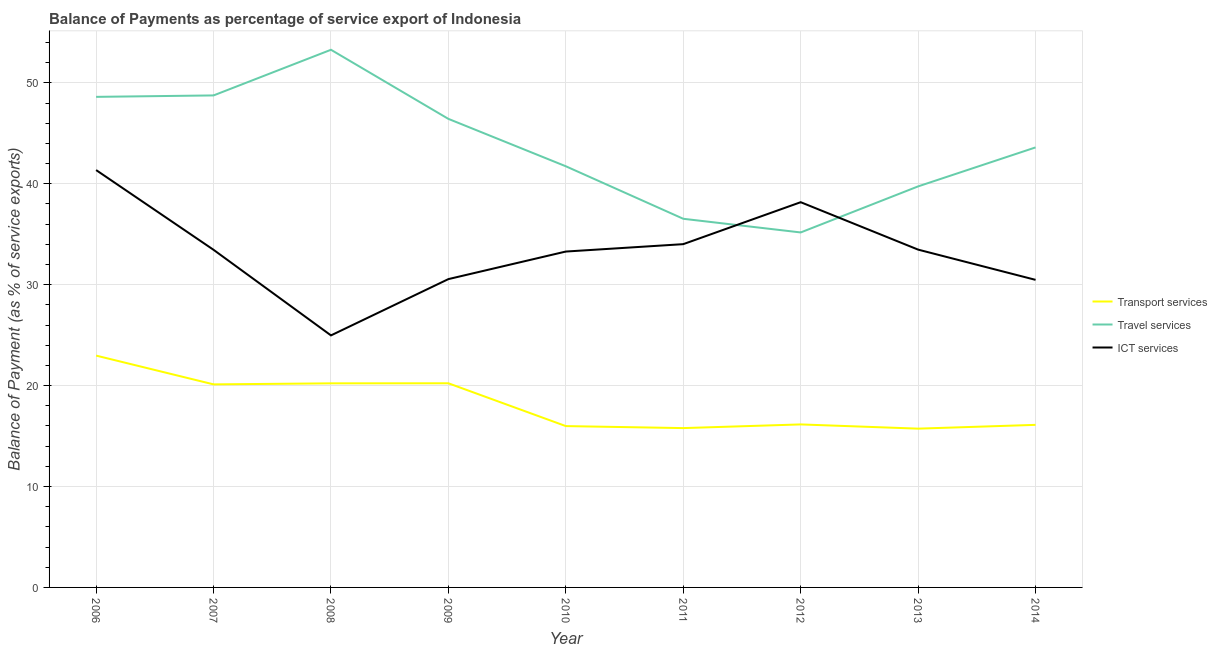How many different coloured lines are there?
Your response must be concise. 3. Does the line corresponding to balance of payment of transport services intersect with the line corresponding to balance of payment of travel services?
Keep it short and to the point. No. Is the number of lines equal to the number of legend labels?
Provide a succinct answer. Yes. What is the balance of payment of transport services in 2009?
Your answer should be compact. 20.23. Across all years, what is the maximum balance of payment of ict services?
Offer a terse response. 41.36. Across all years, what is the minimum balance of payment of travel services?
Keep it short and to the point. 35.18. What is the total balance of payment of transport services in the graph?
Your answer should be very brief. 163.34. What is the difference between the balance of payment of transport services in 2011 and that in 2014?
Ensure brevity in your answer.  -0.32. What is the difference between the balance of payment of travel services in 2012 and the balance of payment of ict services in 2008?
Your answer should be compact. 10.2. What is the average balance of payment of travel services per year?
Provide a succinct answer. 43.77. In the year 2010, what is the difference between the balance of payment of transport services and balance of payment of travel services?
Your response must be concise. -25.75. What is the ratio of the balance of payment of transport services in 2006 to that in 2008?
Make the answer very short. 1.14. Is the difference between the balance of payment of transport services in 2006 and 2014 greater than the difference between the balance of payment of ict services in 2006 and 2014?
Your response must be concise. No. What is the difference between the highest and the second highest balance of payment of travel services?
Ensure brevity in your answer.  4.52. What is the difference between the highest and the lowest balance of payment of transport services?
Your answer should be compact. 7.24. Are the values on the major ticks of Y-axis written in scientific E-notation?
Your answer should be very brief. No. Does the graph contain grids?
Ensure brevity in your answer.  Yes. Where does the legend appear in the graph?
Give a very brief answer. Center right. How are the legend labels stacked?
Offer a terse response. Vertical. What is the title of the graph?
Provide a short and direct response. Balance of Payments as percentage of service export of Indonesia. What is the label or title of the Y-axis?
Offer a very short reply. Balance of Payment (as % of service exports). What is the Balance of Payment (as % of service exports) in Transport services in 2006?
Keep it short and to the point. 22.98. What is the Balance of Payment (as % of service exports) of Travel services in 2006?
Provide a succinct answer. 48.62. What is the Balance of Payment (as % of service exports) of ICT services in 2006?
Your response must be concise. 41.36. What is the Balance of Payment (as % of service exports) in Transport services in 2007?
Provide a succinct answer. 20.12. What is the Balance of Payment (as % of service exports) in Travel services in 2007?
Ensure brevity in your answer.  48.76. What is the Balance of Payment (as % of service exports) of ICT services in 2007?
Your answer should be very brief. 33.46. What is the Balance of Payment (as % of service exports) in Transport services in 2008?
Offer a very short reply. 20.22. What is the Balance of Payment (as % of service exports) in Travel services in 2008?
Give a very brief answer. 53.28. What is the Balance of Payment (as % of service exports) in ICT services in 2008?
Offer a very short reply. 24.98. What is the Balance of Payment (as % of service exports) in Transport services in 2009?
Make the answer very short. 20.23. What is the Balance of Payment (as % of service exports) in Travel services in 2009?
Your answer should be very brief. 46.43. What is the Balance of Payment (as % of service exports) of ICT services in 2009?
Your answer should be very brief. 30.56. What is the Balance of Payment (as % of service exports) of Transport services in 2010?
Your response must be concise. 15.99. What is the Balance of Payment (as % of service exports) in Travel services in 2010?
Your response must be concise. 41.74. What is the Balance of Payment (as % of service exports) in ICT services in 2010?
Your answer should be compact. 33.29. What is the Balance of Payment (as % of service exports) of Transport services in 2011?
Provide a short and direct response. 15.79. What is the Balance of Payment (as % of service exports) in Travel services in 2011?
Give a very brief answer. 36.53. What is the Balance of Payment (as % of service exports) of ICT services in 2011?
Make the answer very short. 34.02. What is the Balance of Payment (as % of service exports) of Transport services in 2012?
Your response must be concise. 16.15. What is the Balance of Payment (as % of service exports) in Travel services in 2012?
Ensure brevity in your answer.  35.18. What is the Balance of Payment (as % of service exports) of ICT services in 2012?
Your response must be concise. 38.18. What is the Balance of Payment (as % of service exports) in Transport services in 2013?
Keep it short and to the point. 15.74. What is the Balance of Payment (as % of service exports) of Travel services in 2013?
Keep it short and to the point. 39.75. What is the Balance of Payment (as % of service exports) in ICT services in 2013?
Your answer should be compact. 33.48. What is the Balance of Payment (as % of service exports) of Transport services in 2014?
Make the answer very short. 16.11. What is the Balance of Payment (as % of service exports) of Travel services in 2014?
Make the answer very short. 43.61. What is the Balance of Payment (as % of service exports) in ICT services in 2014?
Your answer should be compact. 30.48. Across all years, what is the maximum Balance of Payment (as % of service exports) in Transport services?
Provide a short and direct response. 22.98. Across all years, what is the maximum Balance of Payment (as % of service exports) of Travel services?
Offer a very short reply. 53.28. Across all years, what is the maximum Balance of Payment (as % of service exports) in ICT services?
Provide a short and direct response. 41.36. Across all years, what is the minimum Balance of Payment (as % of service exports) in Transport services?
Offer a terse response. 15.74. Across all years, what is the minimum Balance of Payment (as % of service exports) of Travel services?
Offer a terse response. 35.18. Across all years, what is the minimum Balance of Payment (as % of service exports) of ICT services?
Offer a terse response. 24.98. What is the total Balance of Payment (as % of service exports) of Transport services in the graph?
Keep it short and to the point. 163.34. What is the total Balance of Payment (as % of service exports) of Travel services in the graph?
Offer a terse response. 393.9. What is the total Balance of Payment (as % of service exports) of ICT services in the graph?
Ensure brevity in your answer.  299.8. What is the difference between the Balance of Payment (as % of service exports) of Transport services in 2006 and that in 2007?
Provide a succinct answer. 2.85. What is the difference between the Balance of Payment (as % of service exports) in Travel services in 2006 and that in 2007?
Offer a terse response. -0.14. What is the difference between the Balance of Payment (as % of service exports) in ICT services in 2006 and that in 2007?
Ensure brevity in your answer.  7.9. What is the difference between the Balance of Payment (as % of service exports) of Transport services in 2006 and that in 2008?
Your response must be concise. 2.75. What is the difference between the Balance of Payment (as % of service exports) of Travel services in 2006 and that in 2008?
Provide a short and direct response. -4.67. What is the difference between the Balance of Payment (as % of service exports) in ICT services in 2006 and that in 2008?
Offer a terse response. 16.39. What is the difference between the Balance of Payment (as % of service exports) of Transport services in 2006 and that in 2009?
Make the answer very short. 2.74. What is the difference between the Balance of Payment (as % of service exports) of Travel services in 2006 and that in 2009?
Ensure brevity in your answer.  2.18. What is the difference between the Balance of Payment (as % of service exports) of ICT services in 2006 and that in 2009?
Your answer should be very brief. 10.81. What is the difference between the Balance of Payment (as % of service exports) in Transport services in 2006 and that in 2010?
Offer a very short reply. 6.99. What is the difference between the Balance of Payment (as % of service exports) in Travel services in 2006 and that in 2010?
Your response must be concise. 6.88. What is the difference between the Balance of Payment (as % of service exports) in ICT services in 2006 and that in 2010?
Keep it short and to the point. 8.07. What is the difference between the Balance of Payment (as % of service exports) in Transport services in 2006 and that in 2011?
Provide a short and direct response. 7.19. What is the difference between the Balance of Payment (as % of service exports) of Travel services in 2006 and that in 2011?
Provide a succinct answer. 12.08. What is the difference between the Balance of Payment (as % of service exports) of ICT services in 2006 and that in 2011?
Offer a terse response. 7.34. What is the difference between the Balance of Payment (as % of service exports) in Transport services in 2006 and that in 2012?
Offer a terse response. 6.82. What is the difference between the Balance of Payment (as % of service exports) of Travel services in 2006 and that in 2012?
Offer a very short reply. 13.44. What is the difference between the Balance of Payment (as % of service exports) in ICT services in 2006 and that in 2012?
Offer a terse response. 3.18. What is the difference between the Balance of Payment (as % of service exports) of Transport services in 2006 and that in 2013?
Your answer should be very brief. 7.24. What is the difference between the Balance of Payment (as % of service exports) in Travel services in 2006 and that in 2013?
Your response must be concise. 8.87. What is the difference between the Balance of Payment (as % of service exports) in ICT services in 2006 and that in 2013?
Offer a very short reply. 7.88. What is the difference between the Balance of Payment (as % of service exports) of Transport services in 2006 and that in 2014?
Provide a short and direct response. 6.87. What is the difference between the Balance of Payment (as % of service exports) in Travel services in 2006 and that in 2014?
Provide a succinct answer. 5.01. What is the difference between the Balance of Payment (as % of service exports) of ICT services in 2006 and that in 2014?
Give a very brief answer. 10.88. What is the difference between the Balance of Payment (as % of service exports) of Transport services in 2007 and that in 2008?
Give a very brief answer. -0.1. What is the difference between the Balance of Payment (as % of service exports) in Travel services in 2007 and that in 2008?
Provide a short and direct response. -4.52. What is the difference between the Balance of Payment (as % of service exports) of ICT services in 2007 and that in 2008?
Your response must be concise. 8.48. What is the difference between the Balance of Payment (as % of service exports) in Transport services in 2007 and that in 2009?
Offer a terse response. -0.11. What is the difference between the Balance of Payment (as % of service exports) in Travel services in 2007 and that in 2009?
Provide a succinct answer. 2.32. What is the difference between the Balance of Payment (as % of service exports) in ICT services in 2007 and that in 2009?
Make the answer very short. 2.9. What is the difference between the Balance of Payment (as % of service exports) of Transport services in 2007 and that in 2010?
Your answer should be very brief. 4.13. What is the difference between the Balance of Payment (as % of service exports) in Travel services in 2007 and that in 2010?
Provide a short and direct response. 7.02. What is the difference between the Balance of Payment (as % of service exports) in ICT services in 2007 and that in 2010?
Provide a short and direct response. 0.17. What is the difference between the Balance of Payment (as % of service exports) in Transport services in 2007 and that in 2011?
Keep it short and to the point. 4.33. What is the difference between the Balance of Payment (as % of service exports) in Travel services in 2007 and that in 2011?
Offer a terse response. 12.22. What is the difference between the Balance of Payment (as % of service exports) of ICT services in 2007 and that in 2011?
Ensure brevity in your answer.  -0.56. What is the difference between the Balance of Payment (as % of service exports) of Transport services in 2007 and that in 2012?
Your answer should be compact. 3.97. What is the difference between the Balance of Payment (as % of service exports) of Travel services in 2007 and that in 2012?
Give a very brief answer. 13.58. What is the difference between the Balance of Payment (as % of service exports) of ICT services in 2007 and that in 2012?
Provide a short and direct response. -4.72. What is the difference between the Balance of Payment (as % of service exports) in Transport services in 2007 and that in 2013?
Give a very brief answer. 4.39. What is the difference between the Balance of Payment (as % of service exports) of Travel services in 2007 and that in 2013?
Offer a very short reply. 9.01. What is the difference between the Balance of Payment (as % of service exports) of ICT services in 2007 and that in 2013?
Keep it short and to the point. -0.02. What is the difference between the Balance of Payment (as % of service exports) in Transport services in 2007 and that in 2014?
Offer a very short reply. 4.01. What is the difference between the Balance of Payment (as % of service exports) in Travel services in 2007 and that in 2014?
Provide a short and direct response. 5.15. What is the difference between the Balance of Payment (as % of service exports) of ICT services in 2007 and that in 2014?
Your response must be concise. 2.98. What is the difference between the Balance of Payment (as % of service exports) of Transport services in 2008 and that in 2009?
Your response must be concise. -0.01. What is the difference between the Balance of Payment (as % of service exports) of Travel services in 2008 and that in 2009?
Your answer should be very brief. 6.85. What is the difference between the Balance of Payment (as % of service exports) of ICT services in 2008 and that in 2009?
Your answer should be very brief. -5.58. What is the difference between the Balance of Payment (as % of service exports) in Transport services in 2008 and that in 2010?
Offer a very short reply. 4.24. What is the difference between the Balance of Payment (as % of service exports) of Travel services in 2008 and that in 2010?
Your answer should be very brief. 11.55. What is the difference between the Balance of Payment (as % of service exports) of ICT services in 2008 and that in 2010?
Give a very brief answer. -8.31. What is the difference between the Balance of Payment (as % of service exports) in Transport services in 2008 and that in 2011?
Your response must be concise. 4.43. What is the difference between the Balance of Payment (as % of service exports) of Travel services in 2008 and that in 2011?
Provide a short and direct response. 16.75. What is the difference between the Balance of Payment (as % of service exports) of ICT services in 2008 and that in 2011?
Make the answer very short. -9.04. What is the difference between the Balance of Payment (as % of service exports) in Transport services in 2008 and that in 2012?
Give a very brief answer. 4.07. What is the difference between the Balance of Payment (as % of service exports) in Travel services in 2008 and that in 2012?
Make the answer very short. 18.1. What is the difference between the Balance of Payment (as % of service exports) in ICT services in 2008 and that in 2012?
Give a very brief answer. -13.2. What is the difference between the Balance of Payment (as % of service exports) in Transport services in 2008 and that in 2013?
Your answer should be compact. 4.49. What is the difference between the Balance of Payment (as % of service exports) in Travel services in 2008 and that in 2013?
Offer a very short reply. 13.54. What is the difference between the Balance of Payment (as % of service exports) in ICT services in 2008 and that in 2013?
Ensure brevity in your answer.  -8.5. What is the difference between the Balance of Payment (as % of service exports) of Transport services in 2008 and that in 2014?
Offer a terse response. 4.11. What is the difference between the Balance of Payment (as % of service exports) in Travel services in 2008 and that in 2014?
Your answer should be very brief. 9.68. What is the difference between the Balance of Payment (as % of service exports) of ICT services in 2008 and that in 2014?
Offer a terse response. -5.5. What is the difference between the Balance of Payment (as % of service exports) of Transport services in 2009 and that in 2010?
Give a very brief answer. 4.24. What is the difference between the Balance of Payment (as % of service exports) in Travel services in 2009 and that in 2010?
Offer a very short reply. 4.7. What is the difference between the Balance of Payment (as % of service exports) in ICT services in 2009 and that in 2010?
Ensure brevity in your answer.  -2.73. What is the difference between the Balance of Payment (as % of service exports) of Transport services in 2009 and that in 2011?
Your answer should be very brief. 4.44. What is the difference between the Balance of Payment (as % of service exports) in Travel services in 2009 and that in 2011?
Provide a short and direct response. 9.9. What is the difference between the Balance of Payment (as % of service exports) of ICT services in 2009 and that in 2011?
Provide a short and direct response. -3.46. What is the difference between the Balance of Payment (as % of service exports) in Transport services in 2009 and that in 2012?
Your response must be concise. 4.08. What is the difference between the Balance of Payment (as % of service exports) of Travel services in 2009 and that in 2012?
Offer a terse response. 11.25. What is the difference between the Balance of Payment (as % of service exports) in ICT services in 2009 and that in 2012?
Offer a very short reply. -7.62. What is the difference between the Balance of Payment (as % of service exports) of Transport services in 2009 and that in 2013?
Provide a succinct answer. 4.49. What is the difference between the Balance of Payment (as % of service exports) of Travel services in 2009 and that in 2013?
Make the answer very short. 6.69. What is the difference between the Balance of Payment (as % of service exports) in ICT services in 2009 and that in 2013?
Keep it short and to the point. -2.92. What is the difference between the Balance of Payment (as % of service exports) in Transport services in 2009 and that in 2014?
Provide a short and direct response. 4.12. What is the difference between the Balance of Payment (as % of service exports) in Travel services in 2009 and that in 2014?
Keep it short and to the point. 2.83. What is the difference between the Balance of Payment (as % of service exports) of ICT services in 2009 and that in 2014?
Provide a short and direct response. 0.08. What is the difference between the Balance of Payment (as % of service exports) in Transport services in 2010 and that in 2011?
Your answer should be very brief. 0.2. What is the difference between the Balance of Payment (as % of service exports) of Travel services in 2010 and that in 2011?
Ensure brevity in your answer.  5.2. What is the difference between the Balance of Payment (as % of service exports) of ICT services in 2010 and that in 2011?
Make the answer very short. -0.73. What is the difference between the Balance of Payment (as % of service exports) of Transport services in 2010 and that in 2012?
Give a very brief answer. -0.17. What is the difference between the Balance of Payment (as % of service exports) in Travel services in 2010 and that in 2012?
Make the answer very short. 6.56. What is the difference between the Balance of Payment (as % of service exports) in ICT services in 2010 and that in 2012?
Your response must be concise. -4.89. What is the difference between the Balance of Payment (as % of service exports) in Transport services in 2010 and that in 2013?
Your answer should be compact. 0.25. What is the difference between the Balance of Payment (as % of service exports) in Travel services in 2010 and that in 2013?
Ensure brevity in your answer.  1.99. What is the difference between the Balance of Payment (as % of service exports) of ICT services in 2010 and that in 2013?
Your response must be concise. -0.19. What is the difference between the Balance of Payment (as % of service exports) in Transport services in 2010 and that in 2014?
Provide a short and direct response. -0.12. What is the difference between the Balance of Payment (as % of service exports) in Travel services in 2010 and that in 2014?
Keep it short and to the point. -1.87. What is the difference between the Balance of Payment (as % of service exports) of ICT services in 2010 and that in 2014?
Keep it short and to the point. 2.81. What is the difference between the Balance of Payment (as % of service exports) in Transport services in 2011 and that in 2012?
Provide a short and direct response. -0.36. What is the difference between the Balance of Payment (as % of service exports) in Travel services in 2011 and that in 2012?
Offer a very short reply. 1.35. What is the difference between the Balance of Payment (as % of service exports) in ICT services in 2011 and that in 2012?
Your response must be concise. -4.16. What is the difference between the Balance of Payment (as % of service exports) in Transport services in 2011 and that in 2013?
Keep it short and to the point. 0.05. What is the difference between the Balance of Payment (as % of service exports) of Travel services in 2011 and that in 2013?
Give a very brief answer. -3.21. What is the difference between the Balance of Payment (as % of service exports) in ICT services in 2011 and that in 2013?
Offer a very short reply. 0.54. What is the difference between the Balance of Payment (as % of service exports) of Transport services in 2011 and that in 2014?
Your answer should be compact. -0.32. What is the difference between the Balance of Payment (as % of service exports) of Travel services in 2011 and that in 2014?
Ensure brevity in your answer.  -7.07. What is the difference between the Balance of Payment (as % of service exports) of ICT services in 2011 and that in 2014?
Make the answer very short. 3.54. What is the difference between the Balance of Payment (as % of service exports) of Transport services in 2012 and that in 2013?
Offer a very short reply. 0.42. What is the difference between the Balance of Payment (as % of service exports) of Travel services in 2012 and that in 2013?
Offer a terse response. -4.57. What is the difference between the Balance of Payment (as % of service exports) of ICT services in 2012 and that in 2013?
Your response must be concise. 4.7. What is the difference between the Balance of Payment (as % of service exports) of Transport services in 2012 and that in 2014?
Keep it short and to the point. 0.04. What is the difference between the Balance of Payment (as % of service exports) in Travel services in 2012 and that in 2014?
Provide a succinct answer. -8.43. What is the difference between the Balance of Payment (as % of service exports) of ICT services in 2012 and that in 2014?
Offer a terse response. 7.7. What is the difference between the Balance of Payment (as % of service exports) of Transport services in 2013 and that in 2014?
Offer a very short reply. -0.37. What is the difference between the Balance of Payment (as % of service exports) in Travel services in 2013 and that in 2014?
Keep it short and to the point. -3.86. What is the difference between the Balance of Payment (as % of service exports) of ICT services in 2013 and that in 2014?
Your answer should be compact. 3. What is the difference between the Balance of Payment (as % of service exports) in Transport services in 2006 and the Balance of Payment (as % of service exports) in Travel services in 2007?
Your answer should be compact. -25.78. What is the difference between the Balance of Payment (as % of service exports) in Transport services in 2006 and the Balance of Payment (as % of service exports) in ICT services in 2007?
Your answer should be compact. -10.48. What is the difference between the Balance of Payment (as % of service exports) of Travel services in 2006 and the Balance of Payment (as % of service exports) of ICT services in 2007?
Offer a very short reply. 15.16. What is the difference between the Balance of Payment (as % of service exports) of Transport services in 2006 and the Balance of Payment (as % of service exports) of Travel services in 2008?
Your answer should be very brief. -30.31. What is the difference between the Balance of Payment (as % of service exports) in Transport services in 2006 and the Balance of Payment (as % of service exports) in ICT services in 2008?
Your answer should be very brief. -2. What is the difference between the Balance of Payment (as % of service exports) of Travel services in 2006 and the Balance of Payment (as % of service exports) of ICT services in 2008?
Offer a terse response. 23.64. What is the difference between the Balance of Payment (as % of service exports) in Transport services in 2006 and the Balance of Payment (as % of service exports) in Travel services in 2009?
Your response must be concise. -23.46. What is the difference between the Balance of Payment (as % of service exports) of Transport services in 2006 and the Balance of Payment (as % of service exports) of ICT services in 2009?
Your answer should be compact. -7.58. What is the difference between the Balance of Payment (as % of service exports) in Travel services in 2006 and the Balance of Payment (as % of service exports) in ICT services in 2009?
Your answer should be very brief. 18.06. What is the difference between the Balance of Payment (as % of service exports) of Transport services in 2006 and the Balance of Payment (as % of service exports) of Travel services in 2010?
Offer a very short reply. -18.76. What is the difference between the Balance of Payment (as % of service exports) of Transport services in 2006 and the Balance of Payment (as % of service exports) of ICT services in 2010?
Your answer should be compact. -10.31. What is the difference between the Balance of Payment (as % of service exports) in Travel services in 2006 and the Balance of Payment (as % of service exports) in ICT services in 2010?
Make the answer very short. 15.33. What is the difference between the Balance of Payment (as % of service exports) of Transport services in 2006 and the Balance of Payment (as % of service exports) of Travel services in 2011?
Offer a terse response. -13.56. What is the difference between the Balance of Payment (as % of service exports) in Transport services in 2006 and the Balance of Payment (as % of service exports) in ICT services in 2011?
Your answer should be very brief. -11.04. What is the difference between the Balance of Payment (as % of service exports) in Travel services in 2006 and the Balance of Payment (as % of service exports) in ICT services in 2011?
Provide a succinct answer. 14.6. What is the difference between the Balance of Payment (as % of service exports) in Transport services in 2006 and the Balance of Payment (as % of service exports) in Travel services in 2012?
Ensure brevity in your answer.  -12.2. What is the difference between the Balance of Payment (as % of service exports) of Transport services in 2006 and the Balance of Payment (as % of service exports) of ICT services in 2012?
Your answer should be very brief. -15.2. What is the difference between the Balance of Payment (as % of service exports) in Travel services in 2006 and the Balance of Payment (as % of service exports) in ICT services in 2012?
Keep it short and to the point. 10.44. What is the difference between the Balance of Payment (as % of service exports) in Transport services in 2006 and the Balance of Payment (as % of service exports) in Travel services in 2013?
Provide a short and direct response. -16.77. What is the difference between the Balance of Payment (as % of service exports) of Transport services in 2006 and the Balance of Payment (as % of service exports) of ICT services in 2013?
Offer a very short reply. -10.5. What is the difference between the Balance of Payment (as % of service exports) of Travel services in 2006 and the Balance of Payment (as % of service exports) of ICT services in 2013?
Offer a very short reply. 15.14. What is the difference between the Balance of Payment (as % of service exports) of Transport services in 2006 and the Balance of Payment (as % of service exports) of Travel services in 2014?
Offer a very short reply. -20.63. What is the difference between the Balance of Payment (as % of service exports) in Transport services in 2006 and the Balance of Payment (as % of service exports) in ICT services in 2014?
Keep it short and to the point. -7.5. What is the difference between the Balance of Payment (as % of service exports) in Travel services in 2006 and the Balance of Payment (as % of service exports) in ICT services in 2014?
Keep it short and to the point. 18.14. What is the difference between the Balance of Payment (as % of service exports) in Transport services in 2007 and the Balance of Payment (as % of service exports) in Travel services in 2008?
Your response must be concise. -33.16. What is the difference between the Balance of Payment (as % of service exports) in Transport services in 2007 and the Balance of Payment (as % of service exports) in ICT services in 2008?
Provide a succinct answer. -4.85. What is the difference between the Balance of Payment (as % of service exports) in Travel services in 2007 and the Balance of Payment (as % of service exports) in ICT services in 2008?
Keep it short and to the point. 23.78. What is the difference between the Balance of Payment (as % of service exports) of Transport services in 2007 and the Balance of Payment (as % of service exports) of Travel services in 2009?
Your answer should be very brief. -26.31. What is the difference between the Balance of Payment (as % of service exports) in Transport services in 2007 and the Balance of Payment (as % of service exports) in ICT services in 2009?
Your response must be concise. -10.43. What is the difference between the Balance of Payment (as % of service exports) of Travel services in 2007 and the Balance of Payment (as % of service exports) of ICT services in 2009?
Offer a very short reply. 18.2. What is the difference between the Balance of Payment (as % of service exports) in Transport services in 2007 and the Balance of Payment (as % of service exports) in Travel services in 2010?
Offer a terse response. -21.61. What is the difference between the Balance of Payment (as % of service exports) of Transport services in 2007 and the Balance of Payment (as % of service exports) of ICT services in 2010?
Ensure brevity in your answer.  -13.16. What is the difference between the Balance of Payment (as % of service exports) of Travel services in 2007 and the Balance of Payment (as % of service exports) of ICT services in 2010?
Offer a terse response. 15.47. What is the difference between the Balance of Payment (as % of service exports) in Transport services in 2007 and the Balance of Payment (as % of service exports) in Travel services in 2011?
Provide a succinct answer. -16.41. What is the difference between the Balance of Payment (as % of service exports) in Transport services in 2007 and the Balance of Payment (as % of service exports) in ICT services in 2011?
Your response must be concise. -13.9. What is the difference between the Balance of Payment (as % of service exports) in Travel services in 2007 and the Balance of Payment (as % of service exports) in ICT services in 2011?
Ensure brevity in your answer.  14.74. What is the difference between the Balance of Payment (as % of service exports) of Transport services in 2007 and the Balance of Payment (as % of service exports) of Travel services in 2012?
Offer a very short reply. -15.06. What is the difference between the Balance of Payment (as % of service exports) of Transport services in 2007 and the Balance of Payment (as % of service exports) of ICT services in 2012?
Keep it short and to the point. -18.05. What is the difference between the Balance of Payment (as % of service exports) of Travel services in 2007 and the Balance of Payment (as % of service exports) of ICT services in 2012?
Provide a succinct answer. 10.58. What is the difference between the Balance of Payment (as % of service exports) in Transport services in 2007 and the Balance of Payment (as % of service exports) in Travel services in 2013?
Ensure brevity in your answer.  -19.62. What is the difference between the Balance of Payment (as % of service exports) of Transport services in 2007 and the Balance of Payment (as % of service exports) of ICT services in 2013?
Provide a short and direct response. -13.35. What is the difference between the Balance of Payment (as % of service exports) of Travel services in 2007 and the Balance of Payment (as % of service exports) of ICT services in 2013?
Make the answer very short. 15.28. What is the difference between the Balance of Payment (as % of service exports) in Transport services in 2007 and the Balance of Payment (as % of service exports) in Travel services in 2014?
Provide a short and direct response. -23.48. What is the difference between the Balance of Payment (as % of service exports) in Transport services in 2007 and the Balance of Payment (as % of service exports) in ICT services in 2014?
Make the answer very short. -10.36. What is the difference between the Balance of Payment (as % of service exports) of Travel services in 2007 and the Balance of Payment (as % of service exports) of ICT services in 2014?
Give a very brief answer. 18.28. What is the difference between the Balance of Payment (as % of service exports) of Transport services in 2008 and the Balance of Payment (as % of service exports) of Travel services in 2009?
Make the answer very short. -26.21. What is the difference between the Balance of Payment (as % of service exports) of Transport services in 2008 and the Balance of Payment (as % of service exports) of ICT services in 2009?
Offer a very short reply. -10.33. What is the difference between the Balance of Payment (as % of service exports) in Travel services in 2008 and the Balance of Payment (as % of service exports) in ICT services in 2009?
Your answer should be very brief. 22.73. What is the difference between the Balance of Payment (as % of service exports) in Transport services in 2008 and the Balance of Payment (as % of service exports) in Travel services in 2010?
Provide a short and direct response. -21.51. What is the difference between the Balance of Payment (as % of service exports) of Transport services in 2008 and the Balance of Payment (as % of service exports) of ICT services in 2010?
Offer a very short reply. -13.06. What is the difference between the Balance of Payment (as % of service exports) of Travel services in 2008 and the Balance of Payment (as % of service exports) of ICT services in 2010?
Your answer should be very brief. 20. What is the difference between the Balance of Payment (as % of service exports) in Transport services in 2008 and the Balance of Payment (as % of service exports) in Travel services in 2011?
Ensure brevity in your answer.  -16.31. What is the difference between the Balance of Payment (as % of service exports) of Transport services in 2008 and the Balance of Payment (as % of service exports) of ICT services in 2011?
Offer a terse response. -13.79. What is the difference between the Balance of Payment (as % of service exports) of Travel services in 2008 and the Balance of Payment (as % of service exports) of ICT services in 2011?
Your answer should be very brief. 19.26. What is the difference between the Balance of Payment (as % of service exports) of Transport services in 2008 and the Balance of Payment (as % of service exports) of Travel services in 2012?
Provide a succinct answer. -14.95. What is the difference between the Balance of Payment (as % of service exports) in Transport services in 2008 and the Balance of Payment (as % of service exports) in ICT services in 2012?
Offer a terse response. -17.95. What is the difference between the Balance of Payment (as % of service exports) of Travel services in 2008 and the Balance of Payment (as % of service exports) of ICT services in 2012?
Offer a very short reply. 15.11. What is the difference between the Balance of Payment (as % of service exports) in Transport services in 2008 and the Balance of Payment (as % of service exports) in Travel services in 2013?
Your answer should be compact. -19.52. What is the difference between the Balance of Payment (as % of service exports) of Transport services in 2008 and the Balance of Payment (as % of service exports) of ICT services in 2013?
Your response must be concise. -13.25. What is the difference between the Balance of Payment (as % of service exports) in Travel services in 2008 and the Balance of Payment (as % of service exports) in ICT services in 2013?
Ensure brevity in your answer.  19.81. What is the difference between the Balance of Payment (as % of service exports) of Transport services in 2008 and the Balance of Payment (as % of service exports) of Travel services in 2014?
Provide a succinct answer. -23.38. What is the difference between the Balance of Payment (as % of service exports) in Transport services in 2008 and the Balance of Payment (as % of service exports) in ICT services in 2014?
Keep it short and to the point. -10.26. What is the difference between the Balance of Payment (as % of service exports) of Travel services in 2008 and the Balance of Payment (as % of service exports) of ICT services in 2014?
Your answer should be very brief. 22.8. What is the difference between the Balance of Payment (as % of service exports) in Transport services in 2009 and the Balance of Payment (as % of service exports) in Travel services in 2010?
Offer a terse response. -21.51. What is the difference between the Balance of Payment (as % of service exports) in Transport services in 2009 and the Balance of Payment (as % of service exports) in ICT services in 2010?
Give a very brief answer. -13.06. What is the difference between the Balance of Payment (as % of service exports) in Travel services in 2009 and the Balance of Payment (as % of service exports) in ICT services in 2010?
Your answer should be compact. 13.15. What is the difference between the Balance of Payment (as % of service exports) of Transport services in 2009 and the Balance of Payment (as % of service exports) of Travel services in 2011?
Make the answer very short. -16.3. What is the difference between the Balance of Payment (as % of service exports) in Transport services in 2009 and the Balance of Payment (as % of service exports) in ICT services in 2011?
Keep it short and to the point. -13.79. What is the difference between the Balance of Payment (as % of service exports) of Travel services in 2009 and the Balance of Payment (as % of service exports) of ICT services in 2011?
Keep it short and to the point. 12.41. What is the difference between the Balance of Payment (as % of service exports) in Transport services in 2009 and the Balance of Payment (as % of service exports) in Travel services in 2012?
Ensure brevity in your answer.  -14.95. What is the difference between the Balance of Payment (as % of service exports) of Transport services in 2009 and the Balance of Payment (as % of service exports) of ICT services in 2012?
Your answer should be compact. -17.95. What is the difference between the Balance of Payment (as % of service exports) of Travel services in 2009 and the Balance of Payment (as % of service exports) of ICT services in 2012?
Your response must be concise. 8.26. What is the difference between the Balance of Payment (as % of service exports) in Transport services in 2009 and the Balance of Payment (as % of service exports) in Travel services in 2013?
Offer a very short reply. -19.51. What is the difference between the Balance of Payment (as % of service exports) of Transport services in 2009 and the Balance of Payment (as % of service exports) of ICT services in 2013?
Give a very brief answer. -13.25. What is the difference between the Balance of Payment (as % of service exports) in Travel services in 2009 and the Balance of Payment (as % of service exports) in ICT services in 2013?
Keep it short and to the point. 12.96. What is the difference between the Balance of Payment (as % of service exports) of Transport services in 2009 and the Balance of Payment (as % of service exports) of Travel services in 2014?
Your answer should be compact. -23.38. What is the difference between the Balance of Payment (as % of service exports) in Transport services in 2009 and the Balance of Payment (as % of service exports) in ICT services in 2014?
Give a very brief answer. -10.25. What is the difference between the Balance of Payment (as % of service exports) of Travel services in 2009 and the Balance of Payment (as % of service exports) of ICT services in 2014?
Your answer should be compact. 15.95. What is the difference between the Balance of Payment (as % of service exports) of Transport services in 2010 and the Balance of Payment (as % of service exports) of Travel services in 2011?
Keep it short and to the point. -20.55. What is the difference between the Balance of Payment (as % of service exports) of Transport services in 2010 and the Balance of Payment (as % of service exports) of ICT services in 2011?
Keep it short and to the point. -18.03. What is the difference between the Balance of Payment (as % of service exports) in Travel services in 2010 and the Balance of Payment (as % of service exports) in ICT services in 2011?
Your response must be concise. 7.72. What is the difference between the Balance of Payment (as % of service exports) of Transport services in 2010 and the Balance of Payment (as % of service exports) of Travel services in 2012?
Provide a succinct answer. -19.19. What is the difference between the Balance of Payment (as % of service exports) in Transport services in 2010 and the Balance of Payment (as % of service exports) in ICT services in 2012?
Make the answer very short. -22.19. What is the difference between the Balance of Payment (as % of service exports) of Travel services in 2010 and the Balance of Payment (as % of service exports) of ICT services in 2012?
Provide a short and direct response. 3.56. What is the difference between the Balance of Payment (as % of service exports) of Transport services in 2010 and the Balance of Payment (as % of service exports) of Travel services in 2013?
Your answer should be compact. -23.76. What is the difference between the Balance of Payment (as % of service exports) in Transport services in 2010 and the Balance of Payment (as % of service exports) in ICT services in 2013?
Ensure brevity in your answer.  -17.49. What is the difference between the Balance of Payment (as % of service exports) in Travel services in 2010 and the Balance of Payment (as % of service exports) in ICT services in 2013?
Your answer should be very brief. 8.26. What is the difference between the Balance of Payment (as % of service exports) in Transport services in 2010 and the Balance of Payment (as % of service exports) in Travel services in 2014?
Offer a very short reply. -27.62. What is the difference between the Balance of Payment (as % of service exports) of Transport services in 2010 and the Balance of Payment (as % of service exports) of ICT services in 2014?
Provide a short and direct response. -14.49. What is the difference between the Balance of Payment (as % of service exports) of Travel services in 2010 and the Balance of Payment (as % of service exports) of ICT services in 2014?
Provide a short and direct response. 11.26. What is the difference between the Balance of Payment (as % of service exports) in Transport services in 2011 and the Balance of Payment (as % of service exports) in Travel services in 2012?
Make the answer very short. -19.39. What is the difference between the Balance of Payment (as % of service exports) of Transport services in 2011 and the Balance of Payment (as % of service exports) of ICT services in 2012?
Offer a very short reply. -22.39. What is the difference between the Balance of Payment (as % of service exports) of Travel services in 2011 and the Balance of Payment (as % of service exports) of ICT services in 2012?
Provide a short and direct response. -1.64. What is the difference between the Balance of Payment (as % of service exports) in Transport services in 2011 and the Balance of Payment (as % of service exports) in Travel services in 2013?
Make the answer very short. -23.96. What is the difference between the Balance of Payment (as % of service exports) in Transport services in 2011 and the Balance of Payment (as % of service exports) in ICT services in 2013?
Provide a succinct answer. -17.69. What is the difference between the Balance of Payment (as % of service exports) of Travel services in 2011 and the Balance of Payment (as % of service exports) of ICT services in 2013?
Provide a short and direct response. 3.06. What is the difference between the Balance of Payment (as % of service exports) in Transport services in 2011 and the Balance of Payment (as % of service exports) in Travel services in 2014?
Offer a terse response. -27.82. What is the difference between the Balance of Payment (as % of service exports) in Transport services in 2011 and the Balance of Payment (as % of service exports) in ICT services in 2014?
Offer a very short reply. -14.69. What is the difference between the Balance of Payment (as % of service exports) in Travel services in 2011 and the Balance of Payment (as % of service exports) in ICT services in 2014?
Ensure brevity in your answer.  6.05. What is the difference between the Balance of Payment (as % of service exports) in Transport services in 2012 and the Balance of Payment (as % of service exports) in Travel services in 2013?
Your response must be concise. -23.59. What is the difference between the Balance of Payment (as % of service exports) in Transport services in 2012 and the Balance of Payment (as % of service exports) in ICT services in 2013?
Ensure brevity in your answer.  -17.32. What is the difference between the Balance of Payment (as % of service exports) in Travel services in 2012 and the Balance of Payment (as % of service exports) in ICT services in 2013?
Keep it short and to the point. 1.7. What is the difference between the Balance of Payment (as % of service exports) of Transport services in 2012 and the Balance of Payment (as % of service exports) of Travel services in 2014?
Offer a very short reply. -27.45. What is the difference between the Balance of Payment (as % of service exports) of Transport services in 2012 and the Balance of Payment (as % of service exports) of ICT services in 2014?
Give a very brief answer. -14.33. What is the difference between the Balance of Payment (as % of service exports) in Travel services in 2012 and the Balance of Payment (as % of service exports) in ICT services in 2014?
Give a very brief answer. 4.7. What is the difference between the Balance of Payment (as % of service exports) in Transport services in 2013 and the Balance of Payment (as % of service exports) in Travel services in 2014?
Your answer should be compact. -27.87. What is the difference between the Balance of Payment (as % of service exports) in Transport services in 2013 and the Balance of Payment (as % of service exports) in ICT services in 2014?
Offer a terse response. -14.74. What is the difference between the Balance of Payment (as % of service exports) in Travel services in 2013 and the Balance of Payment (as % of service exports) in ICT services in 2014?
Your response must be concise. 9.26. What is the average Balance of Payment (as % of service exports) of Transport services per year?
Offer a terse response. 18.15. What is the average Balance of Payment (as % of service exports) in Travel services per year?
Offer a terse response. 43.77. What is the average Balance of Payment (as % of service exports) in ICT services per year?
Give a very brief answer. 33.31. In the year 2006, what is the difference between the Balance of Payment (as % of service exports) of Transport services and Balance of Payment (as % of service exports) of Travel services?
Give a very brief answer. -25.64. In the year 2006, what is the difference between the Balance of Payment (as % of service exports) of Transport services and Balance of Payment (as % of service exports) of ICT services?
Keep it short and to the point. -18.39. In the year 2006, what is the difference between the Balance of Payment (as % of service exports) in Travel services and Balance of Payment (as % of service exports) in ICT services?
Provide a short and direct response. 7.25. In the year 2007, what is the difference between the Balance of Payment (as % of service exports) in Transport services and Balance of Payment (as % of service exports) in Travel services?
Provide a short and direct response. -28.64. In the year 2007, what is the difference between the Balance of Payment (as % of service exports) of Transport services and Balance of Payment (as % of service exports) of ICT services?
Offer a very short reply. -13.34. In the year 2007, what is the difference between the Balance of Payment (as % of service exports) in Travel services and Balance of Payment (as % of service exports) in ICT services?
Your response must be concise. 15.3. In the year 2008, what is the difference between the Balance of Payment (as % of service exports) of Transport services and Balance of Payment (as % of service exports) of Travel services?
Give a very brief answer. -33.06. In the year 2008, what is the difference between the Balance of Payment (as % of service exports) in Transport services and Balance of Payment (as % of service exports) in ICT services?
Provide a succinct answer. -4.75. In the year 2008, what is the difference between the Balance of Payment (as % of service exports) in Travel services and Balance of Payment (as % of service exports) in ICT services?
Ensure brevity in your answer.  28.31. In the year 2009, what is the difference between the Balance of Payment (as % of service exports) in Transport services and Balance of Payment (as % of service exports) in Travel services?
Ensure brevity in your answer.  -26.2. In the year 2009, what is the difference between the Balance of Payment (as % of service exports) in Transport services and Balance of Payment (as % of service exports) in ICT services?
Offer a very short reply. -10.33. In the year 2009, what is the difference between the Balance of Payment (as % of service exports) in Travel services and Balance of Payment (as % of service exports) in ICT services?
Ensure brevity in your answer.  15.88. In the year 2010, what is the difference between the Balance of Payment (as % of service exports) in Transport services and Balance of Payment (as % of service exports) in Travel services?
Your answer should be very brief. -25.75. In the year 2010, what is the difference between the Balance of Payment (as % of service exports) in Transport services and Balance of Payment (as % of service exports) in ICT services?
Provide a succinct answer. -17.3. In the year 2010, what is the difference between the Balance of Payment (as % of service exports) of Travel services and Balance of Payment (as % of service exports) of ICT services?
Provide a succinct answer. 8.45. In the year 2011, what is the difference between the Balance of Payment (as % of service exports) in Transport services and Balance of Payment (as % of service exports) in Travel services?
Offer a very short reply. -20.74. In the year 2011, what is the difference between the Balance of Payment (as % of service exports) of Transport services and Balance of Payment (as % of service exports) of ICT services?
Make the answer very short. -18.23. In the year 2011, what is the difference between the Balance of Payment (as % of service exports) in Travel services and Balance of Payment (as % of service exports) in ICT services?
Provide a succinct answer. 2.51. In the year 2012, what is the difference between the Balance of Payment (as % of service exports) of Transport services and Balance of Payment (as % of service exports) of Travel services?
Your response must be concise. -19.02. In the year 2012, what is the difference between the Balance of Payment (as % of service exports) of Transport services and Balance of Payment (as % of service exports) of ICT services?
Your response must be concise. -22.02. In the year 2012, what is the difference between the Balance of Payment (as % of service exports) of Travel services and Balance of Payment (as % of service exports) of ICT services?
Your answer should be very brief. -3. In the year 2013, what is the difference between the Balance of Payment (as % of service exports) of Transport services and Balance of Payment (as % of service exports) of Travel services?
Provide a short and direct response. -24.01. In the year 2013, what is the difference between the Balance of Payment (as % of service exports) in Transport services and Balance of Payment (as % of service exports) in ICT services?
Your response must be concise. -17.74. In the year 2013, what is the difference between the Balance of Payment (as % of service exports) of Travel services and Balance of Payment (as % of service exports) of ICT services?
Ensure brevity in your answer.  6.27. In the year 2014, what is the difference between the Balance of Payment (as % of service exports) in Transport services and Balance of Payment (as % of service exports) in Travel services?
Your answer should be compact. -27.5. In the year 2014, what is the difference between the Balance of Payment (as % of service exports) in Transport services and Balance of Payment (as % of service exports) in ICT services?
Offer a very short reply. -14.37. In the year 2014, what is the difference between the Balance of Payment (as % of service exports) of Travel services and Balance of Payment (as % of service exports) of ICT services?
Make the answer very short. 13.13. What is the ratio of the Balance of Payment (as % of service exports) of Transport services in 2006 to that in 2007?
Ensure brevity in your answer.  1.14. What is the ratio of the Balance of Payment (as % of service exports) in ICT services in 2006 to that in 2007?
Your answer should be very brief. 1.24. What is the ratio of the Balance of Payment (as % of service exports) of Transport services in 2006 to that in 2008?
Your response must be concise. 1.14. What is the ratio of the Balance of Payment (as % of service exports) in Travel services in 2006 to that in 2008?
Offer a terse response. 0.91. What is the ratio of the Balance of Payment (as % of service exports) in ICT services in 2006 to that in 2008?
Offer a terse response. 1.66. What is the ratio of the Balance of Payment (as % of service exports) of Transport services in 2006 to that in 2009?
Ensure brevity in your answer.  1.14. What is the ratio of the Balance of Payment (as % of service exports) of Travel services in 2006 to that in 2009?
Your answer should be very brief. 1.05. What is the ratio of the Balance of Payment (as % of service exports) of ICT services in 2006 to that in 2009?
Offer a terse response. 1.35. What is the ratio of the Balance of Payment (as % of service exports) of Transport services in 2006 to that in 2010?
Give a very brief answer. 1.44. What is the ratio of the Balance of Payment (as % of service exports) of Travel services in 2006 to that in 2010?
Your answer should be compact. 1.16. What is the ratio of the Balance of Payment (as % of service exports) of ICT services in 2006 to that in 2010?
Your answer should be compact. 1.24. What is the ratio of the Balance of Payment (as % of service exports) in Transport services in 2006 to that in 2011?
Offer a terse response. 1.46. What is the ratio of the Balance of Payment (as % of service exports) of Travel services in 2006 to that in 2011?
Offer a terse response. 1.33. What is the ratio of the Balance of Payment (as % of service exports) of ICT services in 2006 to that in 2011?
Keep it short and to the point. 1.22. What is the ratio of the Balance of Payment (as % of service exports) of Transport services in 2006 to that in 2012?
Offer a very short reply. 1.42. What is the ratio of the Balance of Payment (as % of service exports) of Travel services in 2006 to that in 2012?
Offer a terse response. 1.38. What is the ratio of the Balance of Payment (as % of service exports) in ICT services in 2006 to that in 2012?
Offer a very short reply. 1.08. What is the ratio of the Balance of Payment (as % of service exports) of Transport services in 2006 to that in 2013?
Your response must be concise. 1.46. What is the ratio of the Balance of Payment (as % of service exports) of Travel services in 2006 to that in 2013?
Keep it short and to the point. 1.22. What is the ratio of the Balance of Payment (as % of service exports) in ICT services in 2006 to that in 2013?
Your answer should be very brief. 1.24. What is the ratio of the Balance of Payment (as % of service exports) in Transport services in 2006 to that in 2014?
Ensure brevity in your answer.  1.43. What is the ratio of the Balance of Payment (as % of service exports) in Travel services in 2006 to that in 2014?
Provide a succinct answer. 1.11. What is the ratio of the Balance of Payment (as % of service exports) of ICT services in 2006 to that in 2014?
Provide a short and direct response. 1.36. What is the ratio of the Balance of Payment (as % of service exports) of Travel services in 2007 to that in 2008?
Make the answer very short. 0.92. What is the ratio of the Balance of Payment (as % of service exports) in ICT services in 2007 to that in 2008?
Give a very brief answer. 1.34. What is the ratio of the Balance of Payment (as % of service exports) of Travel services in 2007 to that in 2009?
Keep it short and to the point. 1.05. What is the ratio of the Balance of Payment (as % of service exports) in ICT services in 2007 to that in 2009?
Offer a very short reply. 1.09. What is the ratio of the Balance of Payment (as % of service exports) of Transport services in 2007 to that in 2010?
Provide a short and direct response. 1.26. What is the ratio of the Balance of Payment (as % of service exports) in Travel services in 2007 to that in 2010?
Offer a terse response. 1.17. What is the ratio of the Balance of Payment (as % of service exports) in Transport services in 2007 to that in 2011?
Your response must be concise. 1.27. What is the ratio of the Balance of Payment (as % of service exports) in Travel services in 2007 to that in 2011?
Ensure brevity in your answer.  1.33. What is the ratio of the Balance of Payment (as % of service exports) of ICT services in 2007 to that in 2011?
Your answer should be compact. 0.98. What is the ratio of the Balance of Payment (as % of service exports) of Transport services in 2007 to that in 2012?
Give a very brief answer. 1.25. What is the ratio of the Balance of Payment (as % of service exports) in Travel services in 2007 to that in 2012?
Your answer should be compact. 1.39. What is the ratio of the Balance of Payment (as % of service exports) in ICT services in 2007 to that in 2012?
Make the answer very short. 0.88. What is the ratio of the Balance of Payment (as % of service exports) of Transport services in 2007 to that in 2013?
Provide a short and direct response. 1.28. What is the ratio of the Balance of Payment (as % of service exports) of Travel services in 2007 to that in 2013?
Offer a very short reply. 1.23. What is the ratio of the Balance of Payment (as % of service exports) of ICT services in 2007 to that in 2013?
Provide a succinct answer. 1. What is the ratio of the Balance of Payment (as % of service exports) of Transport services in 2007 to that in 2014?
Give a very brief answer. 1.25. What is the ratio of the Balance of Payment (as % of service exports) in Travel services in 2007 to that in 2014?
Make the answer very short. 1.12. What is the ratio of the Balance of Payment (as % of service exports) of ICT services in 2007 to that in 2014?
Provide a short and direct response. 1.1. What is the ratio of the Balance of Payment (as % of service exports) in Travel services in 2008 to that in 2009?
Your response must be concise. 1.15. What is the ratio of the Balance of Payment (as % of service exports) in ICT services in 2008 to that in 2009?
Offer a very short reply. 0.82. What is the ratio of the Balance of Payment (as % of service exports) of Transport services in 2008 to that in 2010?
Your answer should be compact. 1.26. What is the ratio of the Balance of Payment (as % of service exports) of Travel services in 2008 to that in 2010?
Make the answer very short. 1.28. What is the ratio of the Balance of Payment (as % of service exports) of ICT services in 2008 to that in 2010?
Offer a very short reply. 0.75. What is the ratio of the Balance of Payment (as % of service exports) of Transport services in 2008 to that in 2011?
Provide a short and direct response. 1.28. What is the ratio of the Balance of Payment (as % of service exports) of Travel services in 2008 to that in 2011?
Your response must be concise. 1.46. What is the ratio of the Balance of Payment (as % of service exports) in ICT services in 2008 to that in 2011?
Provide a succinct answer. 0.73. What is the ratio of the Balance of Payment (as % of service exports) of Transport services in 2008 to that in 2012?
Provide a succinct answer. 1.25. What is the ratio of the Balance of Payment (as % of service exports) in Travel services in 2008 to that in 2012?
Your answer should be very brief. 1.51. What is the ratio of the Balance of Payment (as % of service exports) in ICT services in 2008 to that in 2012?
Ensure brevity in your answer.  0.65. What is the ratio of the Balance of Payment (as % of service exports) in Transport services in 2008 to that in 2013?
Make the answer very short. 1.29. What is the ratio of the Balance of Payment (as % of service exports) of Travel services in 2008 to that in 2013?
Provide a short and direct response. 1.34. What is the ratio of the Balance of Payment (as % of service exports) of ICT services in 2008 to that in 2013?
Your answer should be very brief. 0.75. What is the ratio of the Balance of Payment (as % of service exports) of Transport services in 2008 to that in 2014?
Ensure brevity in your answer.  1.26. What is the ratio of the Balance of Payment (as % of service exports) of Travel services in 2008 to that in 2014?
Make the answer very short. 1.22. What is the ratio of the Balance of Payment (as % of service exports) in ICT services in 2008 to that in 2014?
Provide a succinct answer. 0.82. What is the ratio of the Balance of Payment (as % of service exports) of Transport services in 2009 to that in 2010?
Ensure brevity in your answer.  1.27. What is the ratio of the Balance of Payment (as % of service exports) of Travel services in 2009 to that in 2010?
Your answer should be very brief. 1.11. What is the ratio of the Balance of Payment (as % of service exports) of ICT services in 2009 to that in 2010?
Ensure brevity in your answer.  0.92. What is the ratio of the Balance of Payment (as % of service exports) in Transport services in 2009 to that in 2011?
Offer a terse response. 1.28. What is the ratio of the Balance of Payment (as % of service exports) of Travel services in 2009 to that in 2011?
Your answer should be very brief. 1.27. What is the ratio of the Balance of Payment (as % of service exports) in ICT services in 2009 to that in 2011?
Your answer should be very brief. 0.9. What is the ratio of the Balance of Payment (as % of service exports) in Transport services in 2009 to that in 2012?
Ensure brevity in your answer.  1.25. What is the ratio of the Balance of Payment (as % of service exports) of Travel services in 2009 to that in 2012?
Offer a very short reply. 1.32. What is the ratio of the Balance of Payment (as % of service exports) in ICT services in 2009 to that in 2012?
Keep it short and to the point. 0.8. What is the ratio of the Balance of Payment (as % of service exports) in Transport services in 2009 to that in 2013?
Keep it short and to the point. 1.29. What is the ratio of the Balance of Payment (as % of service exports) of Travel services in 2009 to that in 2013?
Provide a succinct answer. 1.17. What is the ratio of the Balance of Payment (as % of service exports) of ICT services in 2009 to that in 2013?
Your answer should be very brief. 0.91. What is the ratio of the Balance of Payment (as % of service exports) of Transport services in 2009 to that in 2014?
Keep it short and to the point. 1.26. What is the ratio of the Balance of Payment (as % of service exports) of Travel services in 2009 to that in 2014?
Your response must be concise. 1.06. What is the ratio of the Balance of Payment (as % of service exports) in ICT services in 2009 to that in 2014?
Ensure brevity in your answer.  1. What is the ratio of the Balance of Payment (as % of service exports) of Transport services in 2010 to that in 2011?
Your answer should be compact. 1.01. What is the ratio of the Balance of Payment (as % of service exports) of Travel services in 2010 to that in 2011?
Your answer should be compact. 1.14. What is the ratio of the Balance of Payment (as % of service exports) in ICT services in 2010 to that in 2011?
Offer a very short reply. 0.98. What is the ratio of the Balance of Payment (as % of service exports) of Travel services in 2010 to that in 2012?
Your answer should be compact. 1.19. What is the ratio of the Balance of Payment (as % of service exports) in ICT services in 2010 to that in 2012?
Provide a succinct answer. 0.87. What is the ratio of the Balance of Payment (as % of service exports) of Travel services in 2010 to that in 2013?
Ensure brevity in your answer.  1.05. What is the ratio of the Balance of Payment (as % of service exports) of Transport services in 2010 to that in 2014?
Your answer should be very brief. 0.99. What is the ratio of the Balance of Payment (as % of service exports) in Travel services in 2010 to that in 2014?
Your response must be concise. 0.96. What is the ratio of the Balance of Payment (as % of service exports) in ICT services in 2010 to that in 2014?
Provide a succinct answer. 1.09. What is the ratio of the Balance of Payment (as % of service exports) in Transport services in 2011 to that in 2012?
Make the answer very short. 0.98. What is the ratio of the Balance of Payment (as % of service exports) of Travel services in 2011 to that in 2012?
Keep it short and to the point. 1.04. What is the ratio of the Balance of Payment (as % of service exports) of ICT services in 2011 to that in 2012?
Give a very brief answer. 0.89. What is the ratio of the Balance of Payment (as % of service exports) of Travel services in 2011 to that in 2013?
Give a very brief answer. 0.92. What is the ratio of the Balance of Payment (as % of service exports) in ICT services in 2011 to that in 2013?
Offer a very short reply. 1.02. What is the ratio of the Balance of Payment (as % of service exports) in Transport services in 2011 to that in 2014?
Make the answer very short. 0.98. What is the ratio of the Balance of Payment (as % of service exports) of Travel services in 2011 to that in 2014?
Your response must be concise. 0.84. What is the ratio of the Balance of Payment (as % of service exports) in ICT services in 2011 to that in 2014?
Provide a succinct answer. 1.12. What is the ratio of the Balance of Payment (as % of service exports) in Transport services in 2012 to that in 2013?
Offer a terse response. 1.03. What is the ratio of the Balance of Payment (as % of service exports) in Travel services in 2012 to that in 2013?
Your response must be concise. 0.89. What is the ratio of the Balance of Payment (as % of service exports) of ICT services in 2012 to that in 2013?
Give a very brief answer. 1.14. What is the ratio of the Balance of Payment (as % of service exports) in Travel services in 2012 to that in 2014?
Keep it short and to the point. 0.81. What is the ratio of the Balance of Payment (as % of service exports) in ICT services in 2012 to that in 2014?
Your response must be concise. 1.25. What is the ratio of the Balance of Payment (as % of service exports) of Transport services in 2013 to that in 2014?
Keep it short and to the point. 0.98. What is the ratio of the Balance of Payment (as % of service exports) of Travel services in 2013 to that in 2014?
Your response must be concise. 0.91. What is the ratio of the Balance of Payment (as % of service exports) of ICT services in 2013 to that in 2014?
Your response must be concise. 1.1. What is the difference between the highest and the second highest Balance of Payment (as % of service exports) in Transport services?
Provide a short and direct response. 2.74. What is the difference between the highest and the second highest Balance of Payment (as % of service exports) of Travel services?
Your response must be concise. 4.52. What is the difference between the highest and the second highest Balance of Payment (as % of service exports) of ICT services?
Offer a terse response. 3.18. What is the difference between the highest and the lowest Balance of Payment (as % of service exports) in Transport services?
Offer a terse response. 7.24. What is the difference between the highest and the lowest Balance of Payment (as % of service exports) of Travel services?
Your answer should be compact. 18.1. What is the difference between the highest and the lowest Balance of Payment (as % of service exports) in ICT services?
Provide a succinct answer. 16.39. 